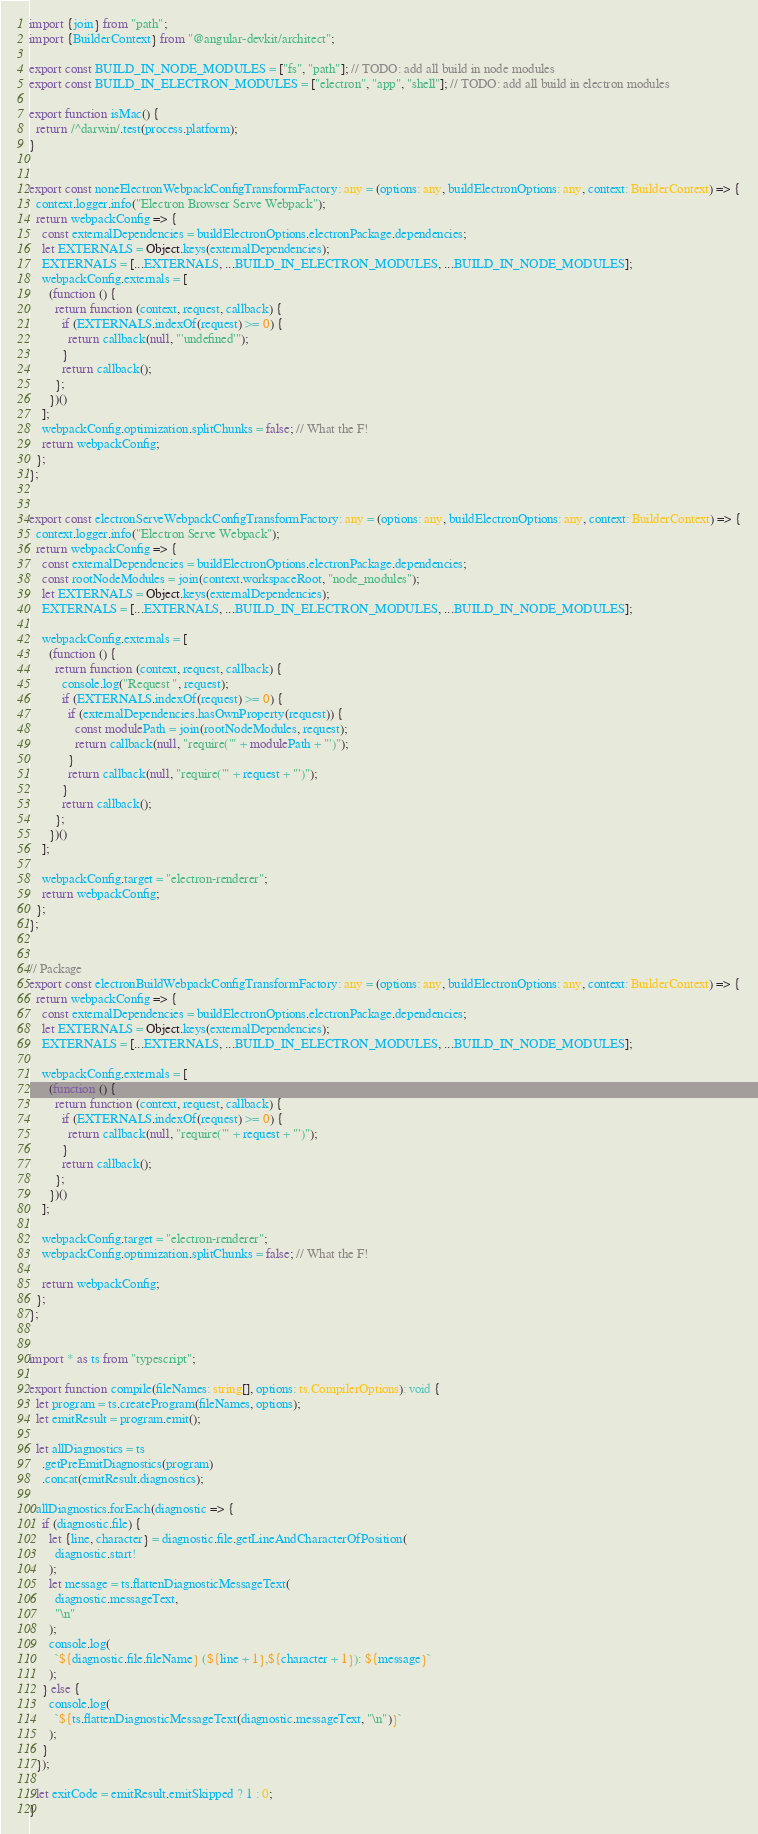<code> <loc_0><loc_0><loc_500><loc_500><_TypeScript_>import {join} from "path";
import {BuilderContext} from "@angular-devkit/architect";

export const BUILD_IN_NODE_MODULES = ["fs", "path"]; // TODO: add all build in node modules
export const BUILD_IN_ELECTRON_MODULES = ["electron", "app", "shell"]; // TODO: add all build in electron modules

export function isMac() {
  return /^darwin/.test(process.platform);
}


export const noneElectronWebpackConfigTransformFactory: any = (options: any, buildElectronOptions: any, context: BuilderContext) => {
  context.logger.info("Electron Browser Serve Webpack");
  return webpackConfig => {
    const externalDependencies = buildElectronOptions.electronPackage.dependencies;
    let EXTERNALS = Object.keys(externalDependencies);
    EXTERNALS = [...EXTERNALS, ...BUILD_IN_ELECTRON_MODULES, ...BUILD_IN_NODE_MODULES];
    webpackConfig.externals = [
      (function () {
        return function (context, request, callback) {
          if (EXTERNALS.indexOf(request) >= 0) {
            return callback(null, "'undefined'");
          }
          return callback();
        };
      })()
    ];
    webpackConfig.optimization.splitChunks = false; // What the F!
    return webpackConfig;
  };
};


export const electronServeWebpackConfigTransformFactory: any = (options: any, buildElectronOptions: any, context: BuilderContext) => {
  context.logger.info("Electron Serve Webpack");
  return webpackConfig => {
    const externalDependencies = buildElectronOptions.electronPackage.dependencies;
    const rootNodeModules = join(context.workspaceRoot, "node_modules");
    let EXTERNALS = Object.keys(externalDependencies);
    EXTERNALS = [...EXTERNALS, ...BUILD_IN_ELECTRON_MODULES, ...BUILD_IN_NODE_MODULES];

    webpackConfig.externals = [
      (function () {
        return function (context, request, callback) {
          console.log("Request ", request);
          if (EXTERNALS.indexOf(request) >= 0) {
            if (externalDependencies.hasOwnProperty(request)) {
              const modulePath = join(rootNodeModules, request);
              return callback(null, "require('" + modulePath + "')");
            }
            return callback(null, "require('" + request + "')");
          }
          return callback();
        };
      })()
    ];

    webpackConfig.target = "electron-renderer";
    return webpackConfig;
  };
};


// Package
export const electronBuildWebpackConfigTransformFactory: any = (options: any, buildElectronOptions: any, context: BuilderContext) => {
  return webpackConfig => {
    const externalDependencies = buildElectronOptions.electronPackage.dependencies;
    let EXTERNALS = Object.keys(externalDependencies);
    EXTERNALS = [...EXTERNALS, ...BUILD_IN_ELECTRON_MODULES, ...BUILD_IN_NODE_MODULES];

    webpackConfig.externals = [
      (function () {
        return function (context, request, callback) {
          if (EXTERNALS.indexOf(request) >= 0) {
            return callback(null, "require('" + request + "')");
          }
          return callback();
        };
      })()
    ];

    webpackConfig.target = "electron-renderer";
    webpackConfig.optimization.splitChunks = false; // What the F!

    return webpackConfig;
  };
};


import * as ts from "typescript";

export function compile(fileNames: string[], options: ts.CompilerOptions): void {
  let program = ts.createProgram(fileNames, options);
  let emitResult = program.emit();

  let allDiagnostics = ts
    .getPreEmitDiagnostics(program)
    .concat(emitResult.diagnostics);

  allDiagnostics.forEach(diagnostic => {
    if (diagnostic.file) {
      let {line, character} = diagnostic.file.getLineAndCharacterOfPosition(
        diagnostic.start!
      );
      let message = ts.flattenDiagnosticMessageText(
        diagnostic.messageText,
        "\n"
      );
      console.log(
        `${diagnostic.file.fileName} (${line + 1},${character + 1}): ${message}`
      );
    } else {
      console.log(
        `${ts.flattenDiagnosticMessageText(diagnostic.messageText, "\n")}`
      );
    }
  });

  let exitCode = emitResult.emitSkipped ? 1 : 0;
}
</code> 